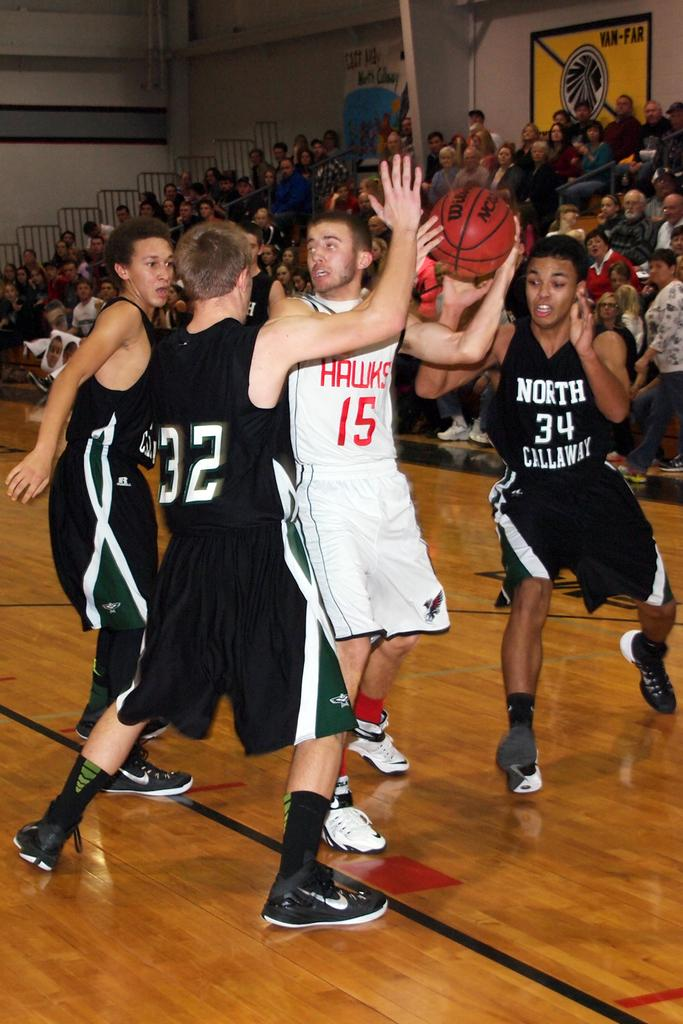<image>
Render a clear and concise summary of the photo. basketball game between hawks in white and north callaway wearing black 